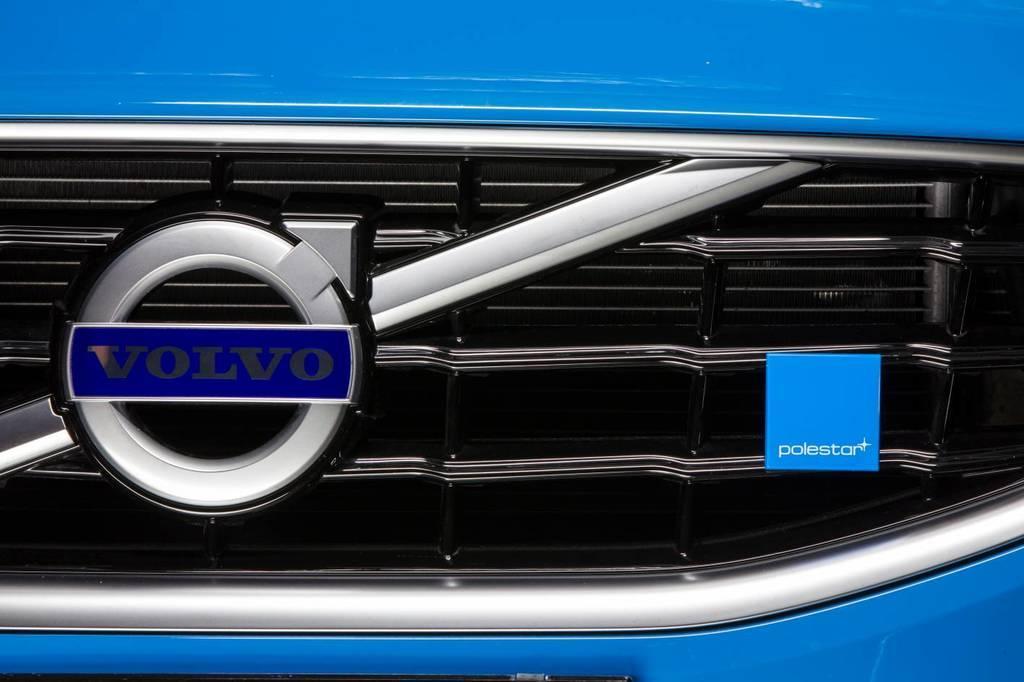Describe this image in one or two sentences. In this image we can see a part of the vehicle, there is a logo attached to the grille. 